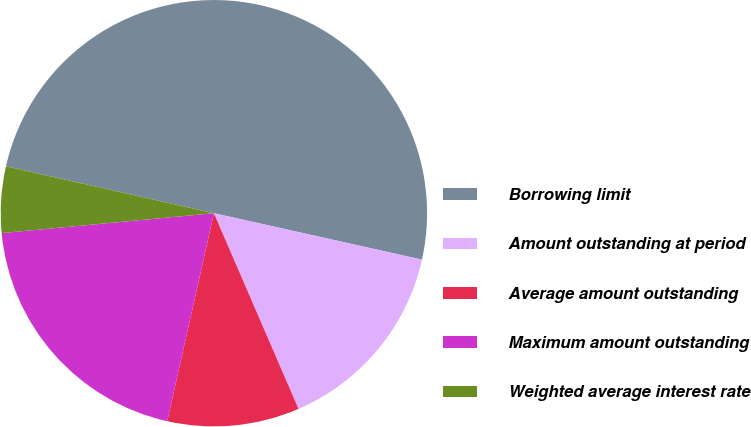Convert chart. <chart><loc_0><loc_0><loc_500><loc_500><pie_chart><fcel>Borrowing limit<fcel>Amount outstanding at period<fcel>Average amount outstanding<fcel>Maximum amount outstanding<fcel>Weighted average interest rate<nl><fcel>49.97%<fcel>15.01%<fcel>10.01%<fcel>20.0%<fcel>5.02%<nl></chart> 